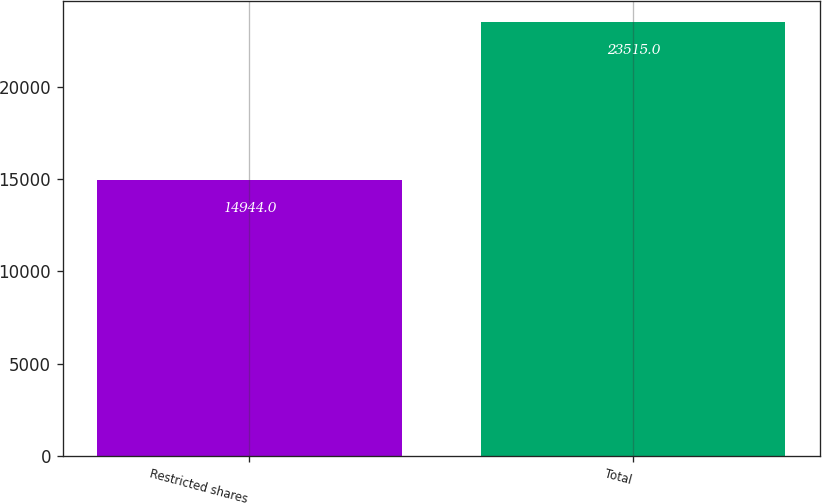Convert chart. <chart><loc_0><loc_0><loc_500><loc_500><bar_chart><fcel>Restricted shares<fcel>Total<nl><fcel>14944<fcel>23515<nl></chart> 